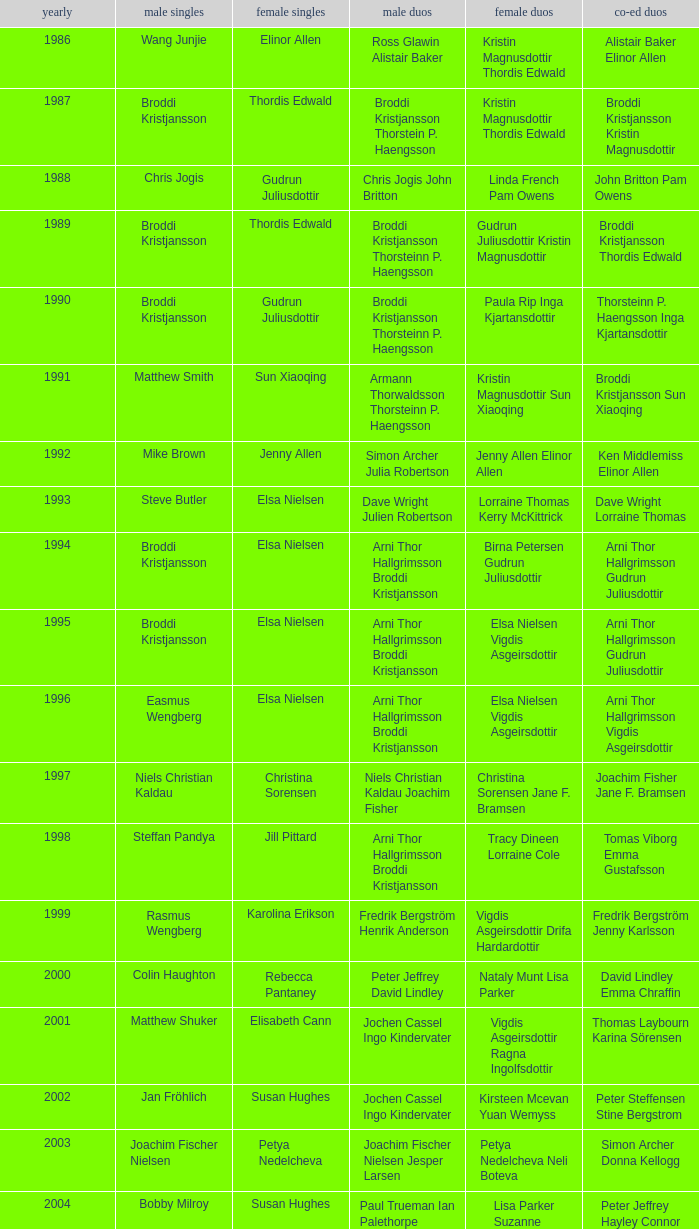In what mixed doubles did Niels Christian Kaldau play in men's singles? Joachim Fisher Jane F. Bramsen. 